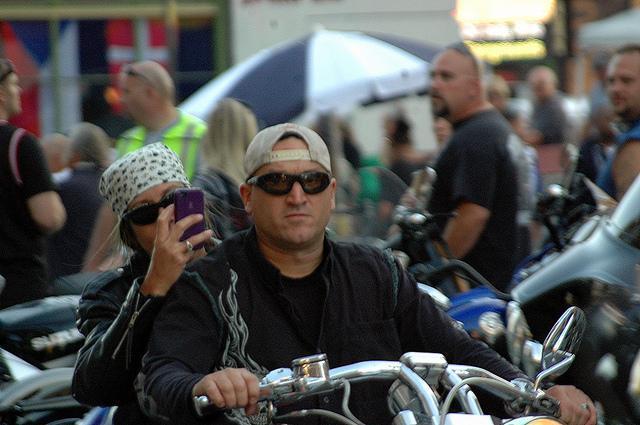Why is the woman wearing a white bandana holding a phone up?
Select the accurate answer and provide justification: `Answer: choice
Rationale: srationale.`
Options: Buying items, playing games, taking pictures, calling 911. Answer: taking pictures.
Rationale: The woman is taking photos. 